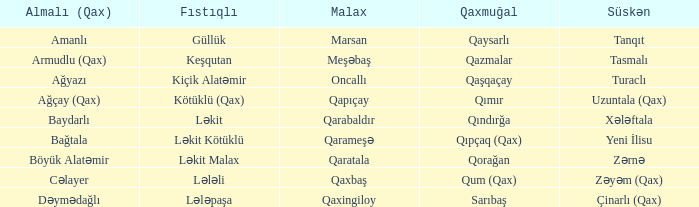Give me the full table as a dictionary. {'header': ['Almalı (Qax)', 'Fıstıqlı', 'Malax', 'Qaxmuğal', 'Süskən'], 'rows': [['Amanlı', 'Güllük', 'Marsan', 'Qaysarlı', 'Tanqıt'], ['Armudlu (Qax)', 'Keşqutan', 'Meşəbaş', 'Qazmalar', 'Tasmalı'], ['Ağyazı', 'Kiçik Alatəmir', 'Oncallı', 'Qaşqaçay', 'Turaclı'], ['Ağçay (Qax)', 'Kötüklü (Qax)', 'Qapıçay', 'Qımır', 'Uzuntala (Qax)'], ['Baydarlı', 'Ləkit', 'Qarabaldır', 'Qındırğa', 'Xələftala'], ['Bağtala', 'Ləkit Kötüklü', 'Qarameşə', 'Qıpçaq (Qax)', 'Yeni İlisu'], ['Böyük Alatəmir', 'Ləkit Malax', 'Qaratala', 'Qorağan', 'Zərnə'], ['Cəlayer', 'Lələli', 'Qaxbaş', 'Qum (Qax)', 'Zəyəm (Qax)'], ['Dəymədağlı', 'Lələpaşa', 'Qaxingiloy', 'Sarıbaş', 'Çinarlı (Qax)']]} What is the Süskən village with a Malax village meşəbaş? Tasmalı. 